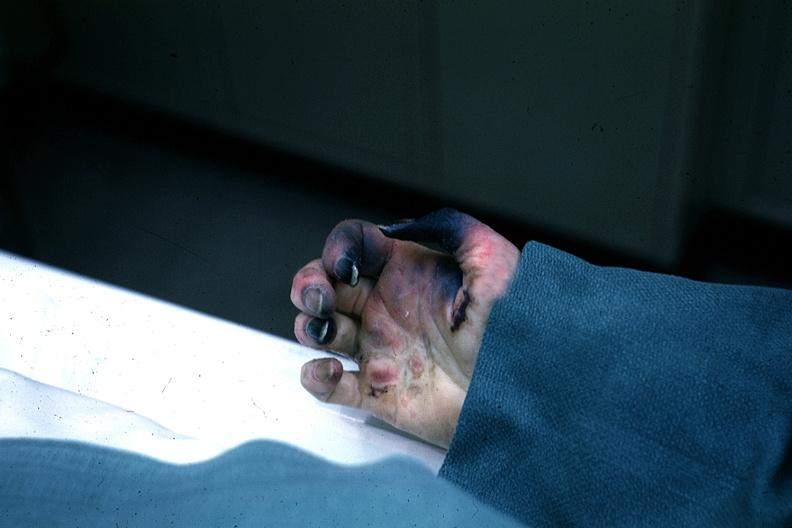what said to be due to embolism?
Answer the question using a single word or phrase. Excellent gangrenous necrosis of fingers 